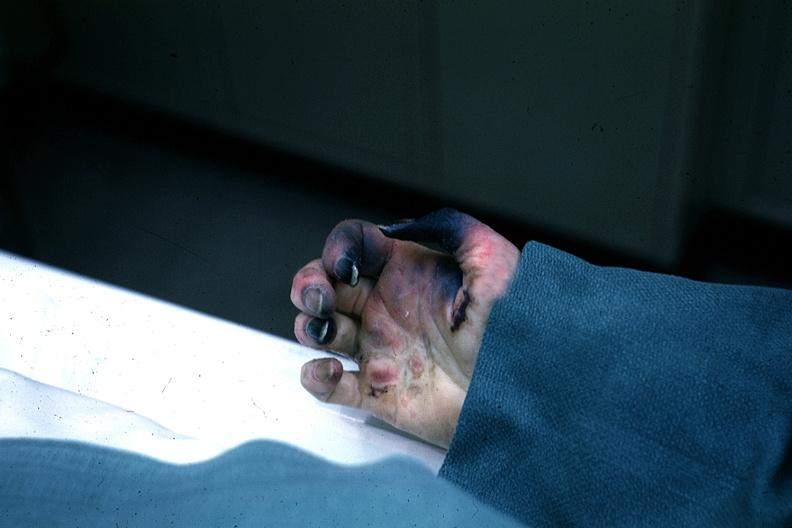what said to be due to embolism?
Answer the question using a single word or phrase. Excellent gangrenous necrosis of fingers 